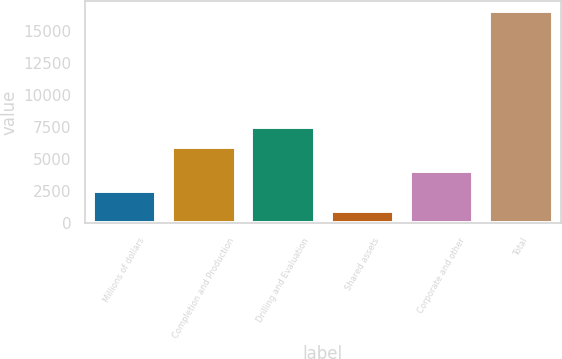Convert chart. <chart><loc_0><loc_0><loc_500><loc_500><bar_chart><fcel>Millions of dollars<fcel>Completion and Production<fcel>Drilling and Evaluation<fcel>Shared assets<fcel>Corporate and other<fcel>Total<nl><fcel>2476.4<fcel>5920<fcel>7482.4<fcel>914<fcel>4038.8<fcel>16538<nl></chart> 